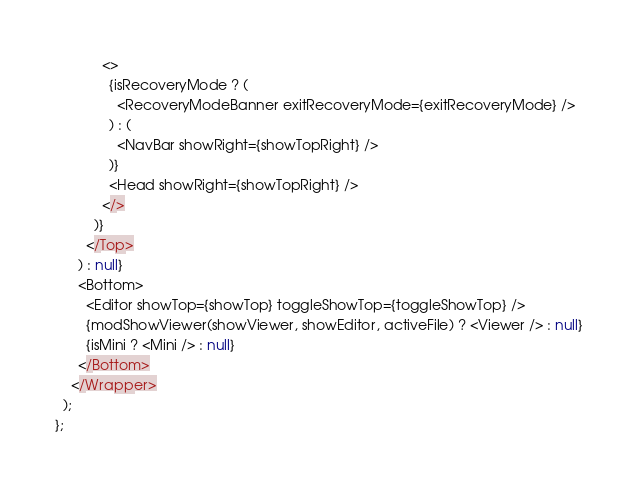<code> <loc_0><loc_0><loc_500><loc_500><_JavaScript_>            <>
              {isRecoveryMode ? (
                <RecoveryModeBanner exitRecoveryMode={exitRecoveryMode} />
              ) : (
                <NavBar showRight={showTopRight} />
              )}
              <Head showRight={showTopRight} />
            </>
          )}
        </Top>
      ) : null}
      <Bottom>
        <Editor showTop={showTop} toggleShowTop={toggleShowTop} />
        {modShowViewer(showViewer, showEditor, activeFile) ? <Viewer /> : null}
        {isMini ? <Mini /> : null}
      </Bottom>
    </Wrapper>
  );
};
</code> 